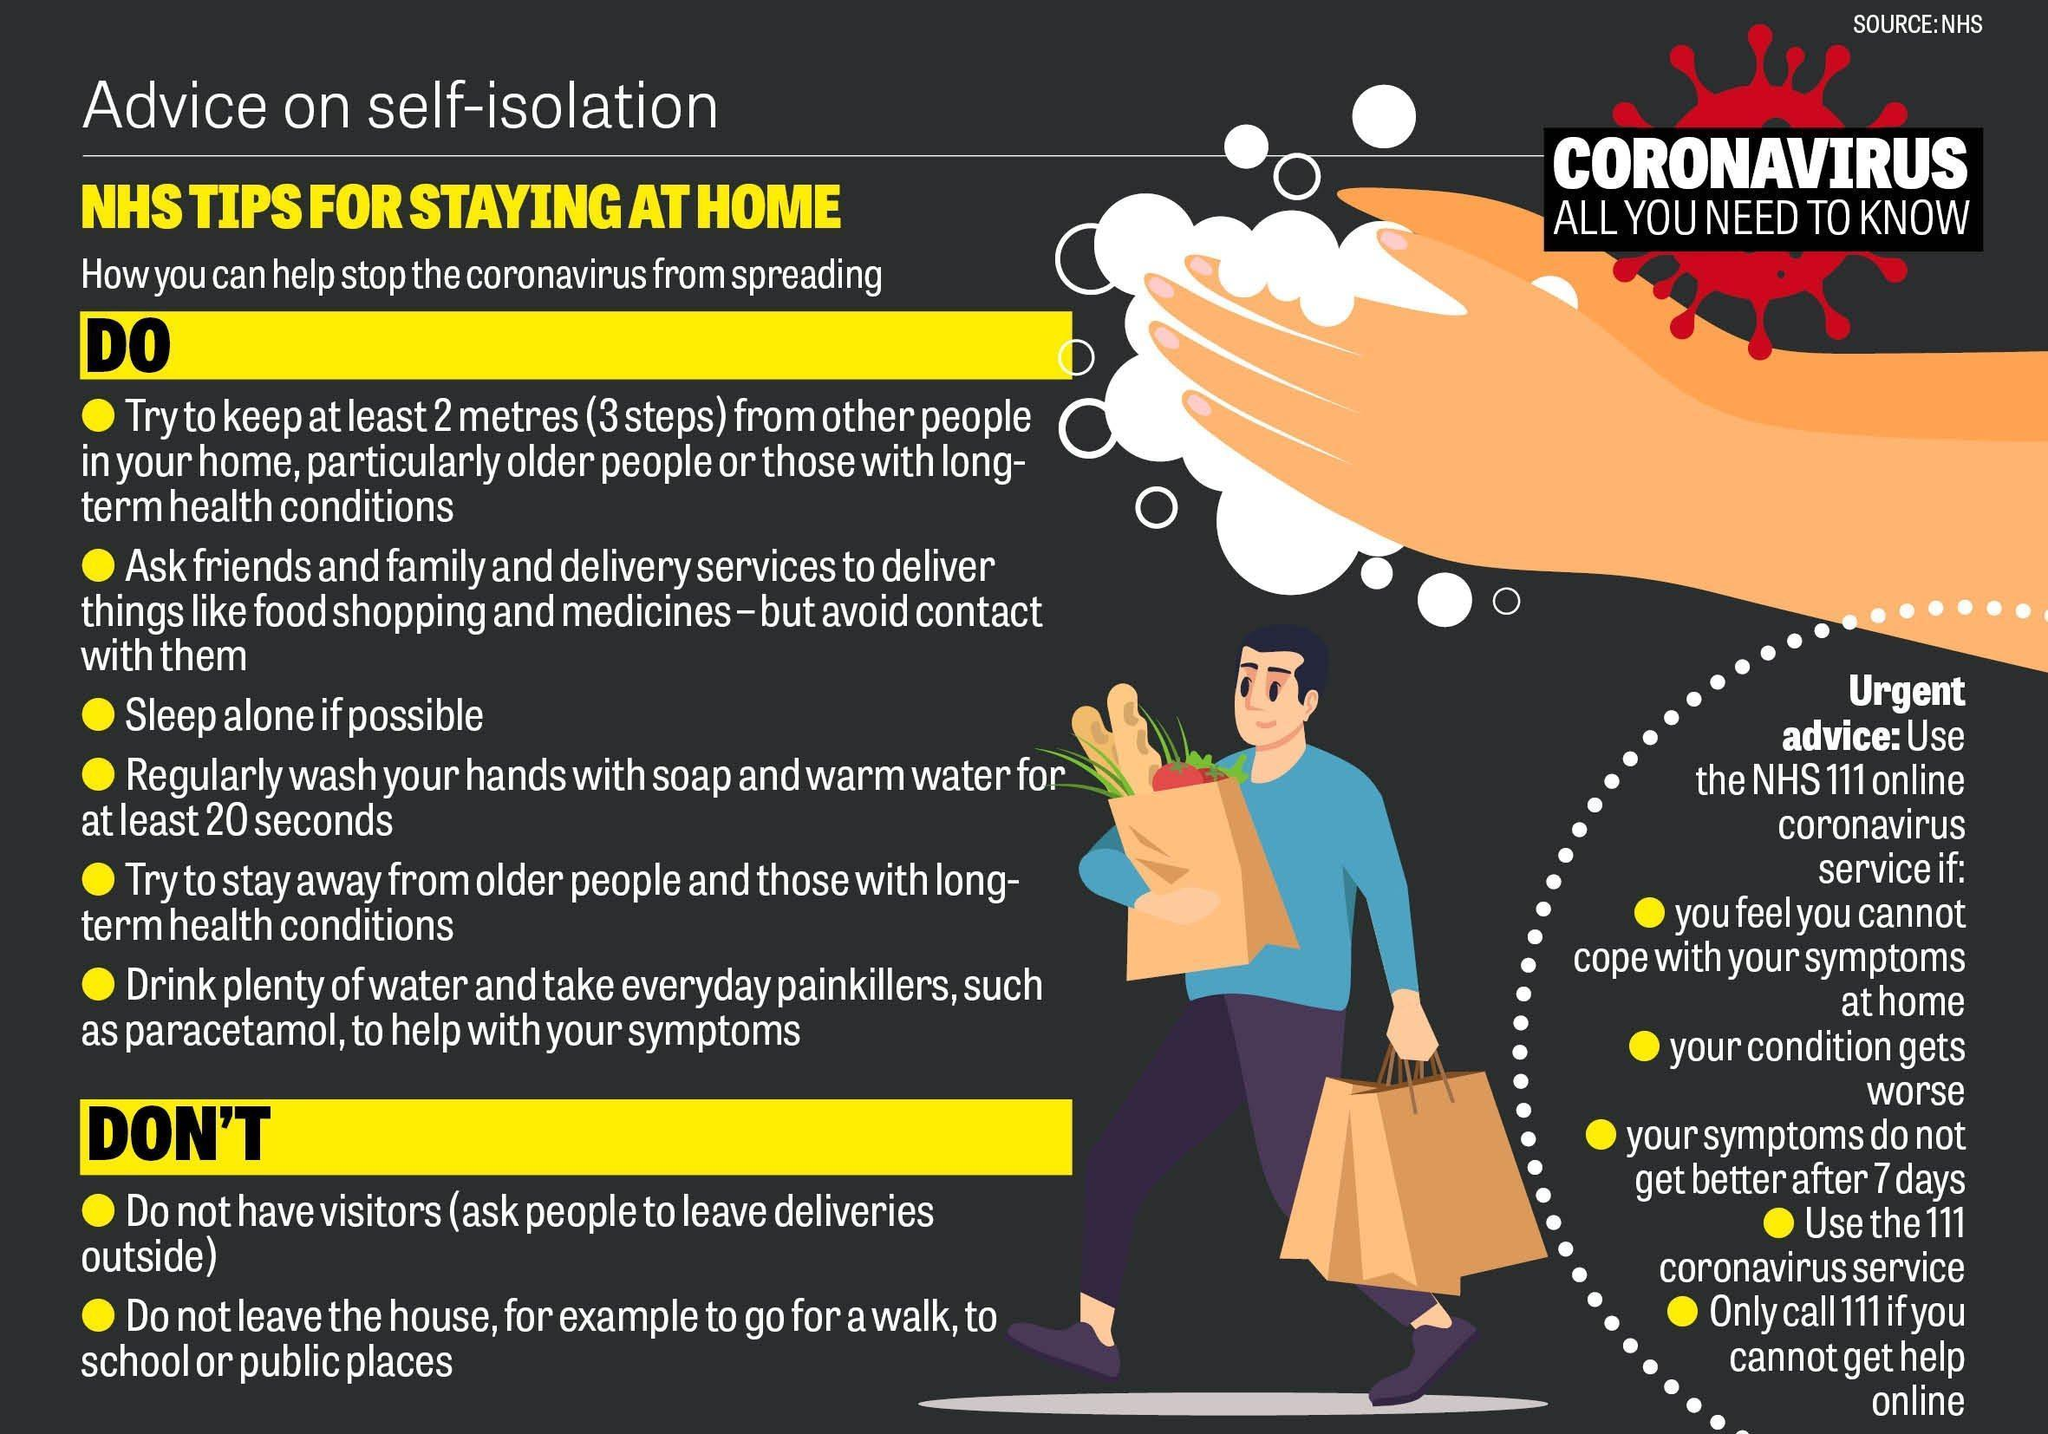How many points under the Do list
Answer the question with a short phrase. 6 3 steps is equal to how many centimetres 200 How many points under the Dont list 2 what is the colour of the bags that the person is holding, brown or white brown What service should we use if our symptoms do not get better after  7 days NHS111 online coronavirus service WHich is the painkiller mentioned paracetamol How many conditions have been mentioned when we can use the NHS11 online coronavirus service 5 